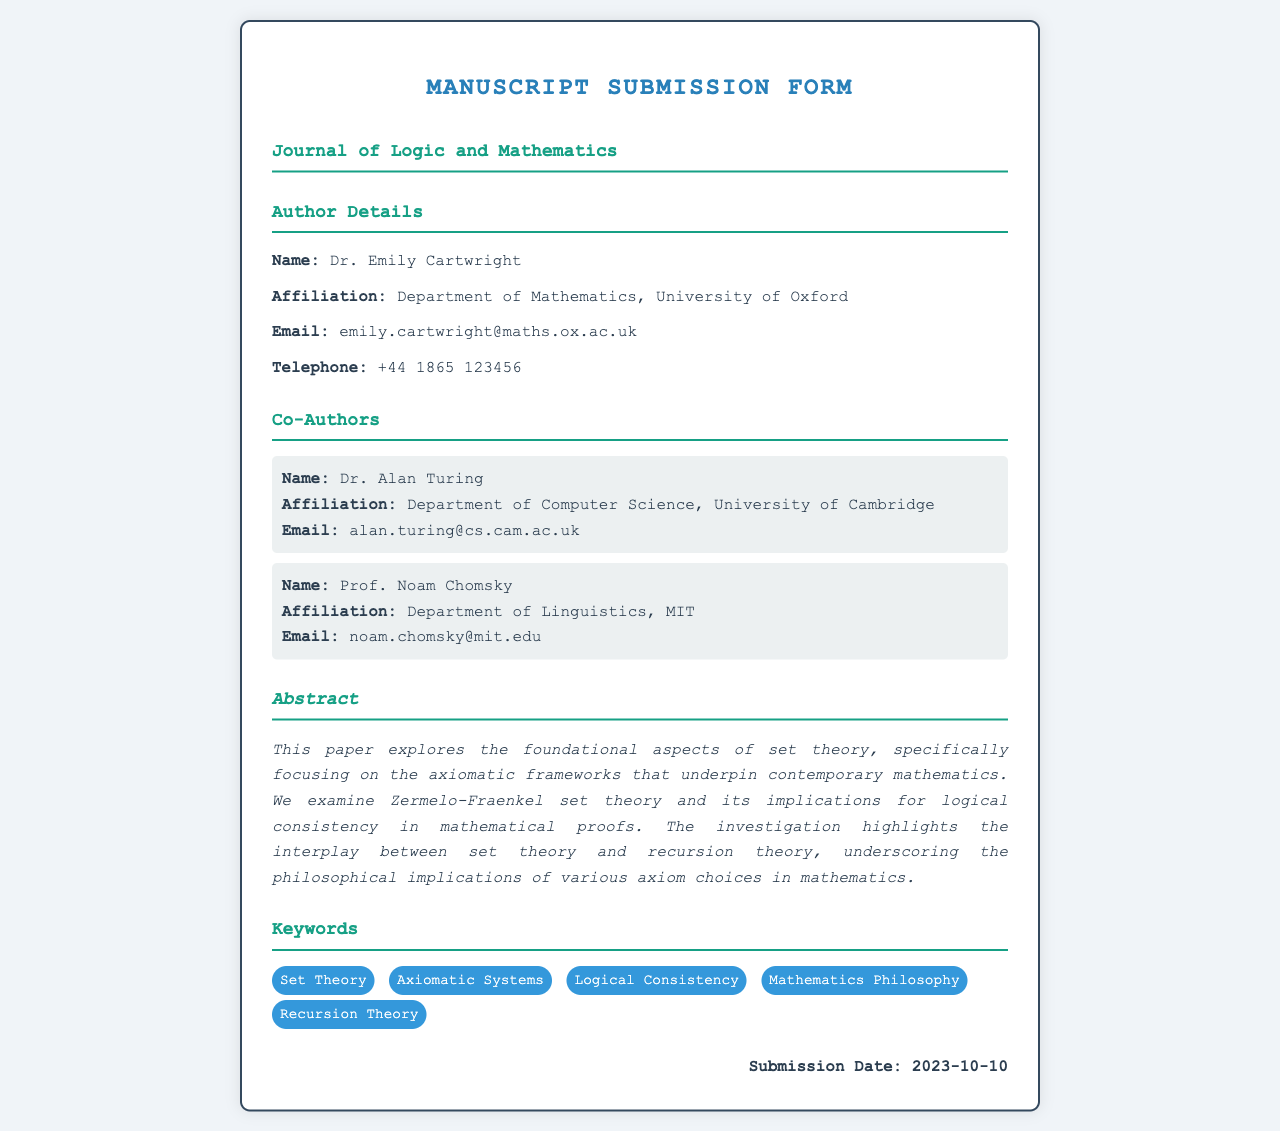What is the author's name? The author's name is indicated in the Author Details section of the document.
Answer: Dr. Emily Cartwright What is the submission date? The submission date is explicitly stated at the bottom of the document.
Answer: 2023-10-10 What is the affiliation of the first co-author? The affiliation of the first co-author can be found in the Co-Authors section.
Answer: Department of Computer Science, University of Cambridge What is the main focus of the paper's abstract? The main focus is derived from the content of the abstract provided in the document.
Answer: Foundational aspects of set theory How many co-authors are listed in the document? The number of co-authors can be counted in the Co-Authors section.
Answer: 2 What philosophical implications are discussed in the abstract? The philosophical implications can be inferred from the content of the abstract that highlights axiom choices in mathematics.
Answer: Various axiom choices in mathematics List one keyword mentioned in the document. Keywords are explicitly provided in the keywords section of the document.
Answer: Set Theory What is Dr. Alan Turing's email address? Dr. Alan Turing's email is provided in the Co-Authors section.
Answer: alan.turing@cs.cam.ac.uk 